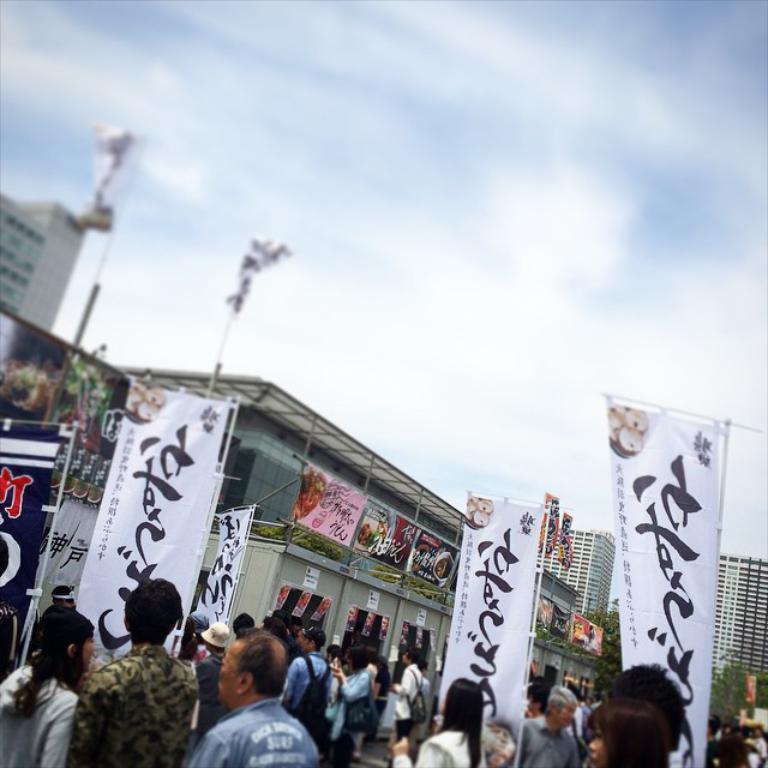Describe this image in one or two sentences. This picture is clicked outside the city. At the bottom of the picture, we see the people are standing. Beside them, we see the banners in white and blue color with some text written on it. In the middle of the picture, we see a building and the hoarding boards. On the left side, we see a building and the poles. There are trees and buildings in the background. At the top, we see the sky. 